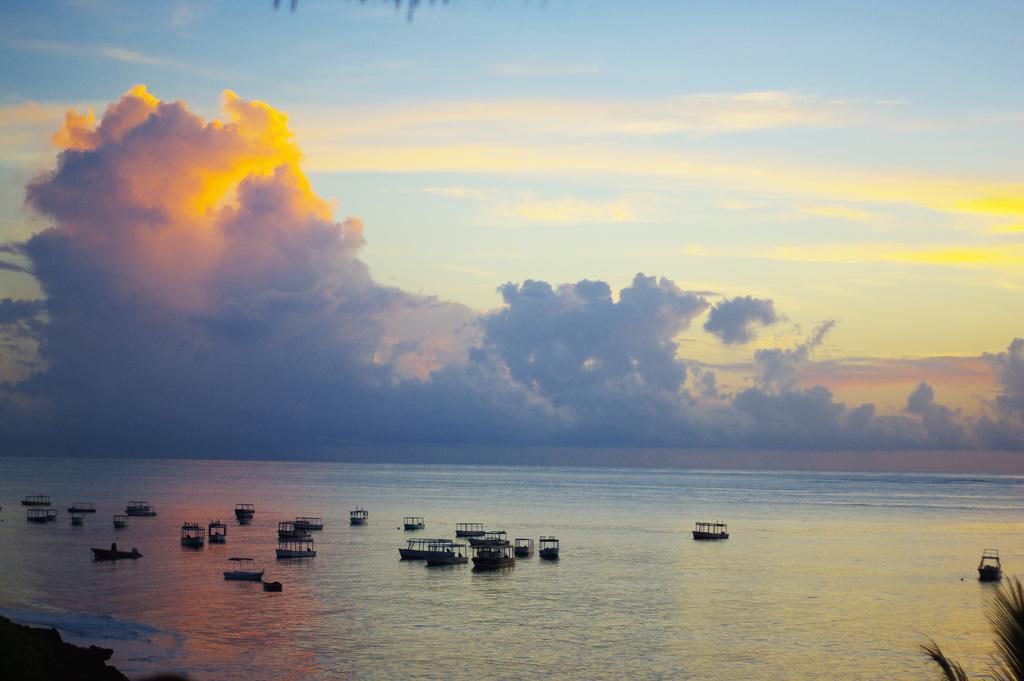Please provide a concise description of this image. In the picture there is water, there are many boats present, there is a clear sky. 